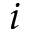Convert formula to latex. <formula><loc_0><loc_0><loc_500><loc_500>i</formula> 